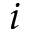Convert formula to latex. <formula><loc_0><loc_0><loc_500><loc_500>i</formula> 